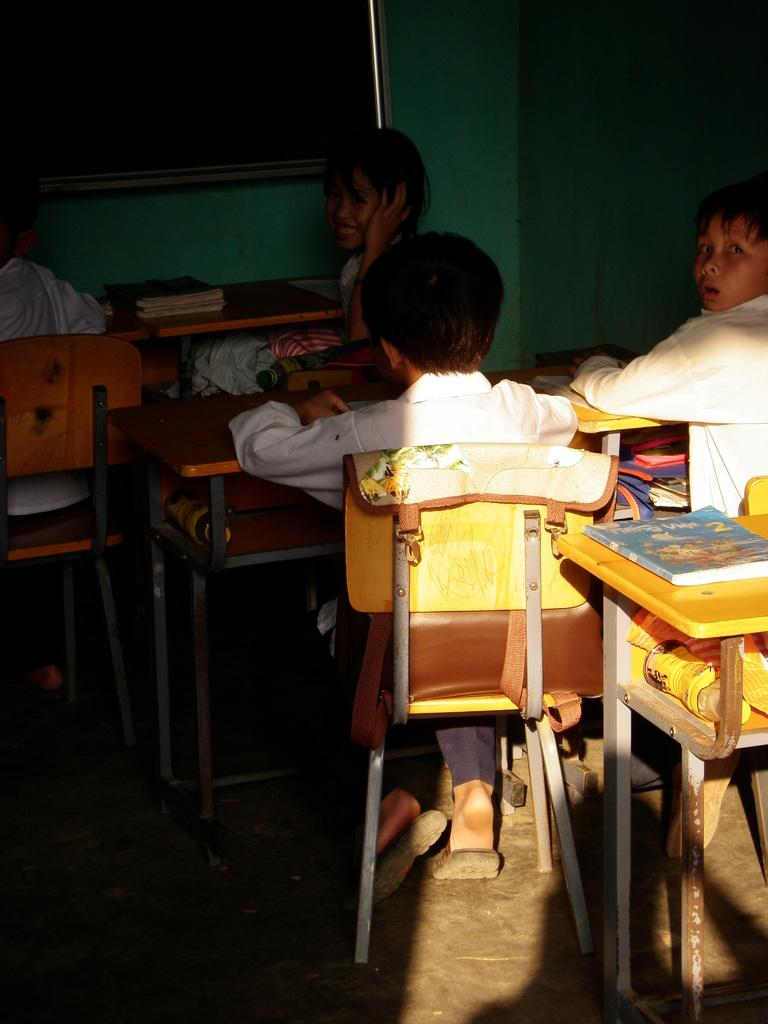Who is present in the image? There are children in the image. What are the children doing in the image? The children are sitting on chairs. What objects are present in the image besides the children? There are tables and a blackboard on the wall in the image. What can be found on the tables? There are books on the tables. What type of twig can be seen growing out of the blackboard in the image? There is no twig growing out of the blackboard in the image. How many letters are visible on the blackboard in the image? There are no letters visible on the blackboard in the image. 